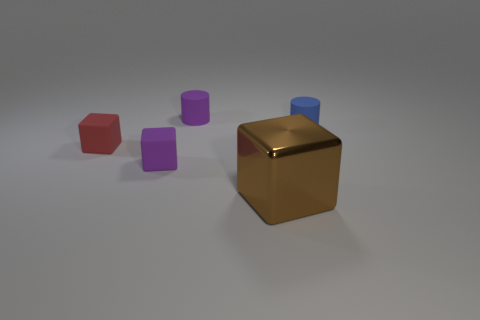Is there anything else that is made of the same material as the brown object?
Your answer should be very brief. No. How many blocks are either small rubber things or small red matte objects?
Make the answer very short. 2. There is a matte object that is right of the tiny cylinder left of the large thing; how many large brown objects are behind it?
Provide a succinct answer. 0. Are there more small purple things than small blue objects?
Ensure brevity in your answer.  Yes. Is the brown metal object the same size as the red rubber thing?
Provide a short and direct response. No. What number of things are small blue rubber things or tiny red rubber objects?
Offer a very short reply. 2. There is a small purple matte thing that is in front of the matte object that is behind the small cylinder that is to the right of the big brown metallic thing; what shape is it?
Your answer should be compact. Cube. Is the material of the cylinder to the left of the brown shiny cube the same as the tiny cylinder that is on the right side of the large thing?
Offer a terse response. Yes. What material is the red thing that is the same shape as the big brown object?
Keep it short and to the point. Rubber. Is there anything else that is the same size as the red object?
Provide a short and direct response. Yes. 